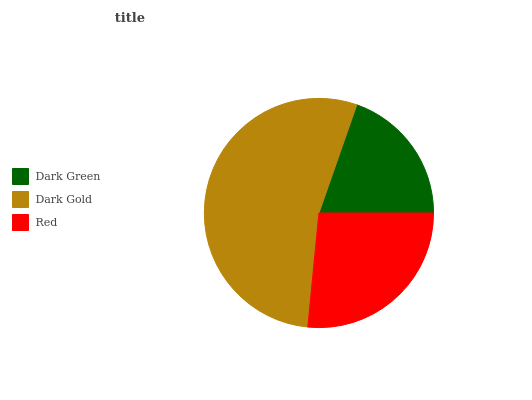Is Dark Green the minimum?
Answer yes or no. Yes. Is Dark Gold the maximum?
Answer yes or no. Yes. Is Red the minimum?
Answer yes or no. No. Is Red the maximum?
Answer yes or no. No. Is Dark Gold greater than Red?
Answer yes or no. Yes. Is Red less than Dark Gold?
Answer yes or no. Yes. Is Red greater than Dark Gold?
Answer yes or no. No. Is Dark Gold less than Red?
Answer yes or no. No. Is Red the high median?
Answer yes or no. Yes. Is Red the low median?
Answer yes or no. Yes. Is Dark Gold the high median?
Answer yes or no. No. Is Dark Gold the low median?
Answer yes or no. No. 